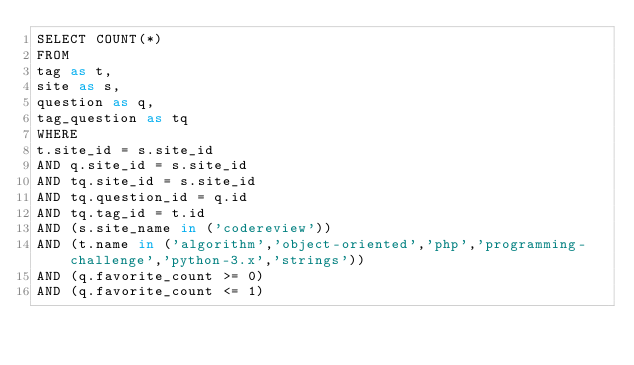Convert code to text. <code><loc_0><loc_0><loc_500><loc_500><_SQL_>SELECT COUNT(*)
FROM
tag as t,
site as s,
question as q,
tag_question as tq
WHERE
t.site_id = s.site_id
AND q.site_id = s.site_id
AND tq.site_id = s.site_id
AND tq.question_id = q.id
AND tq.tag_id = t.id
AND (s.site_name in ('codereview'))
AND (t.name in ('algorithm','object-oriented','php','programming-challenge','python-3.x','strings'))
AND (q.favorite_count >= 0)
AND (q.favorite_count <= 1)
</code> 